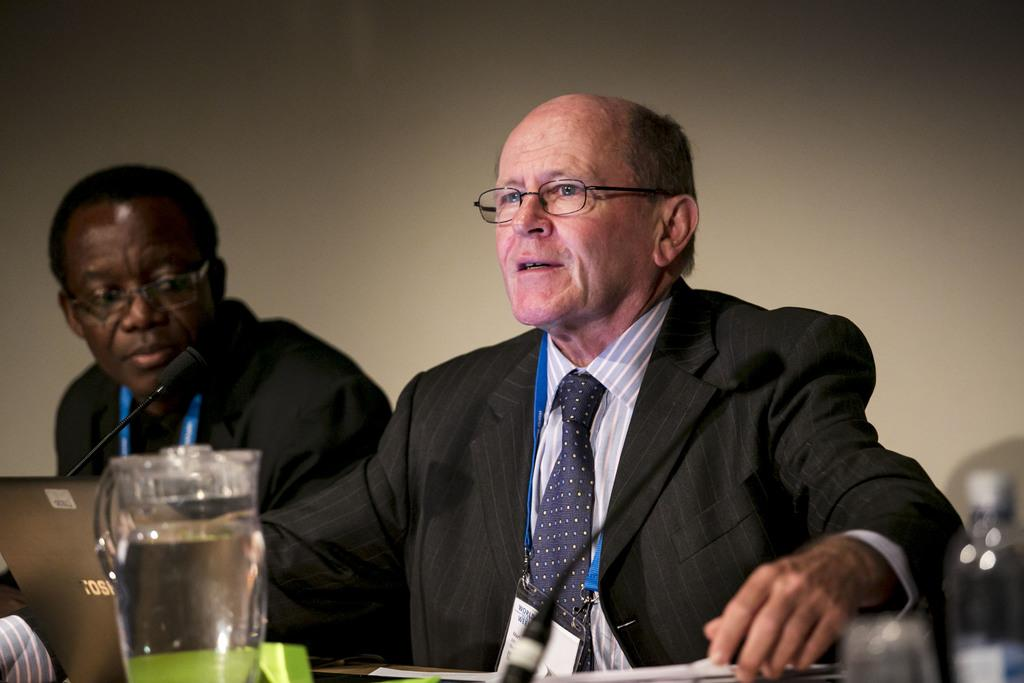What are the people in the image doing? The people in the image are sitting on chairs. What is present on the table in the image? There is a glass, a water jug, a mic with a stand, and a laptop on the table. What might the people be using the glass and water jug for? The glass and water jug might be used for drinking water. What can be inferred about the people in the image based on their attire? The people in the image are wearing ID cards, which might suggest they are at a workplace or event. What type of trail can be seen in the image? There is no trail present in the image; it features people sitting on chairs with a table and various objects. 